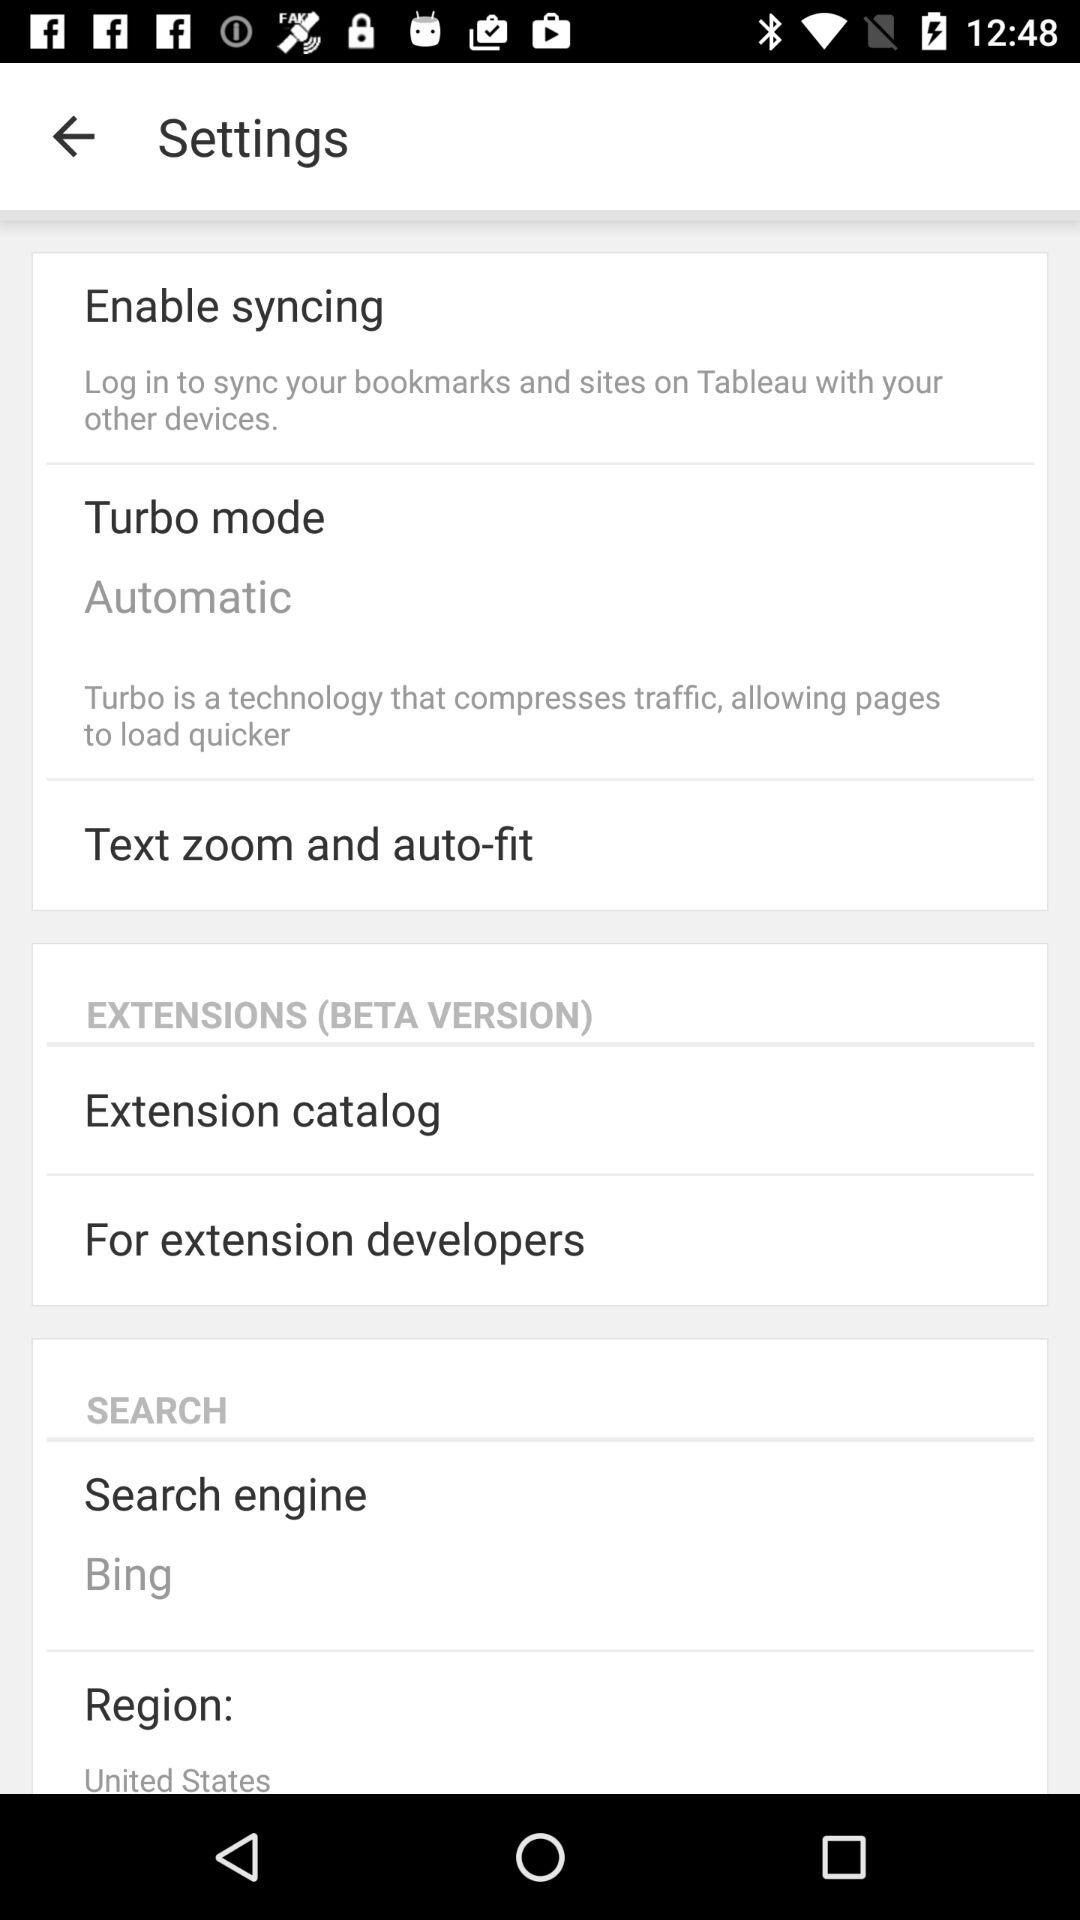What is the region? The region is the United States. 